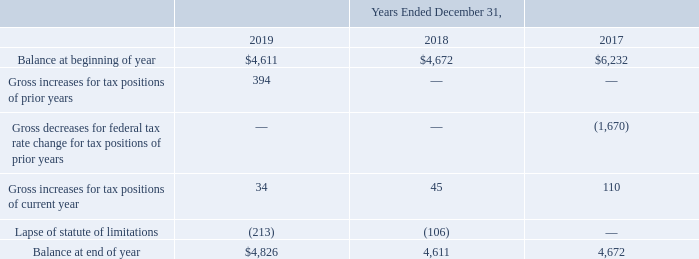The Company maintains liabilities for uncertain tax positions. These liabilities involve considerable judgment and estimation and are continuously monitored by management based on the best information available, including changes in tax regulations, the outcome of relevant court cases, and other information. A reconciliation of the beginning and ending amount of gross unrecognized tax benefits is as follows (in thousands):
The unrecognized tax benefits relate primarily to federal and state research and development credits and intercompany profit on the transfer of certain IP rights to one of the Company’s foreign subsidiaries as part of the Company’s tax reorganization completed in 2015. The Company’s policy is to account for interest and penalties related to uncertain tax positions as a component of income tax expense. As of December 31, 2019, the Company accrued interest or penalties related to uncertain tax positions in the amount of $25,000. As of December 31, 2019, the total amount of unrecognized tax benefits that would affect the Company’s effective tax rate, if recognized, is $97,000.
Because the Company has net operating loss and credit carryforwards, there are open statutes of limitations in which federal, state and foreign taxing authorities may examine the Company’s tax returns for all years from 2000 through the current period.
How does the company account for interest and penalties related to uncertain tax positions? As a component of income tax expense. What was the total amount of unrecognized tax benefits that would affect the Company’s effective tax rate as of December 31, 2019? $97,000. What was the Gross increases for tax positions of prior years in 2019, 2018 and 2017?
Answer scale should be: thousand. 394, 0, 0. In which year was the Balance at beginning of year less than 5,000 thousands? Locate and analyze balance at beginning of year in row 3
answer: 2019, 2018. What was the change in the Gross increases for tax positions of prior years from 2018 to 2019?
Answer scale should be: thousand. 394 - 0
Answer: 394. What was the average Gross increases for tax positions of current year for 2017-2019?
Answer scale should be: thousand. (34 + 45 + 110) / 3
Answer: 63. 